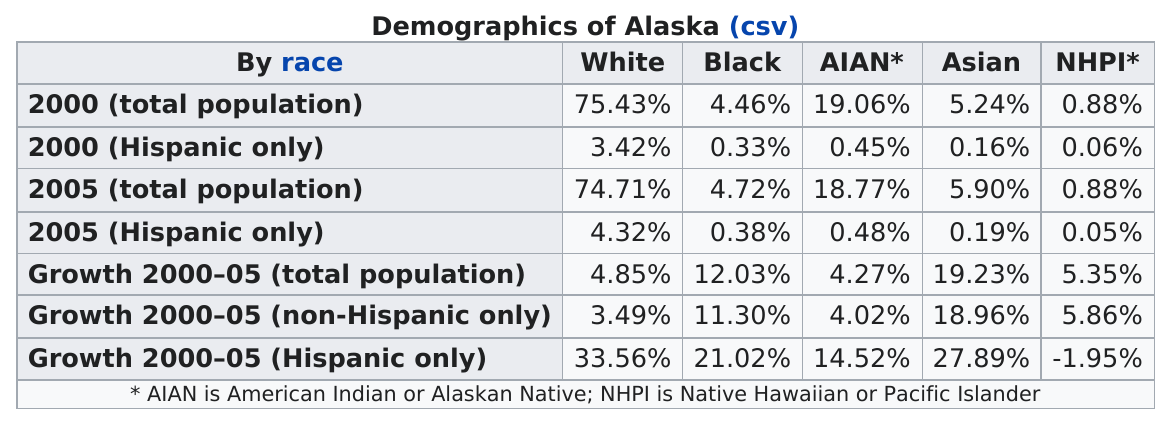Identify some key points in this picture. The black population either grew more or less than the white population as a percentage of the total population, according to the data. In the 2005 survey, 0.19% of Hispanic individuals identified as Asian. The Hispanic population had the greatest growth from 2000 to 2005 among all racial groups, with a significant increase of 31.2%. In contrast, the white population showed a more modest growth of 0.9% during the same period. The total population growth of American Indians was below that of Native Hawaiian and Pacific Islanders. The most recent recorded percentage of the black population is 4.72%. 